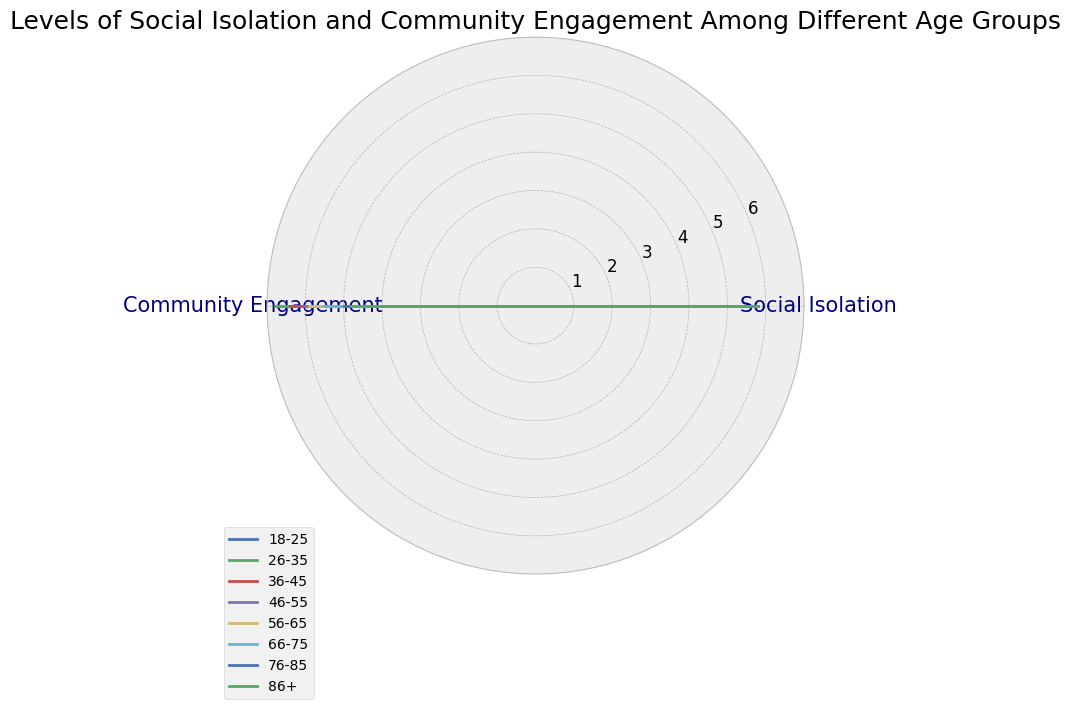What age group exhibits the highest level of social isolation? The age group with the highest value on the social isolation axis indicates the highest level of social isolation. Checking the plot, the age group 86+ has the highest social isolation value.
Answer: 86+ Which age group has the lowest level of community engagement? The age group with the lowest value on the community engagement axis indicates the lowest level of community engagement. From the plot, the age group 86+ has the lowest community engagement value.
Answer: 86+ Compare the levels of social isolation between the 18-25 and 76-85 age groups. Which one is higher and by how much? The social isolation level of the 18-25 age group is 3.2, and for the 76-85 age group, it is 5.1. Subtracting 3.2 from 5.1 gives the difference. Since 5.1 is greater than 3.2, the 76-85 age group has higher social isolation by 1.9.
Answer: 76-85 by 1.9 Identify the age group with the highest community engagement and determine how much higher it is compared to the age group with the second-highest community engagement. The highest community engagement is observed in the 26-35 age group at 6.8. The second-highest community engagement is observed in the 18-25 age group at 6.5. Subtraction shows the difference as 0.3.
Answer: 26-35, higher by 0.3 What is the average level of social isolation across all age groups? The social isolation values for each age group are: 3.2, 2.9, 3.0, 3.5, 4.0, 4.5, 5.1, 5.8. Summing these values and then dividing by the number of age groups (8) gives the average. (3.2 + 2.9 + 3.0 + 3.5 + 4.0 + 4.5 + 5.1 + 5.8) / 8 = 32 / 8 = 4.
Answer: 4 How does the level of community engagement for the 56-65 age group compare visually to that of the 26-35 age group? By visual inspection, on the community engagement axis, the 56-65 age group has a visibly lower value than the 26-35 age group. This is because the length of the line for the 56-65 age group doesn't reach as far outward as that for the 26-35 age group.
Answer: Lower What trend is observable in the levels of social isolation as age increases? As age increases, the levels of social isolation generally show an increasing trend. Each subsequent older age group exhibits a higher level of social isolation on the axis.
Answer: Increases Which two age groups have the most similar levels of community engagement and what is their difference? The community engagement values need to be compared visually. The 18-25 and 36-45 age groups both show similar levels: 6.5 and 6.4, respectively. The difference is
Answer: 18-25 and 36-45; 0.1 